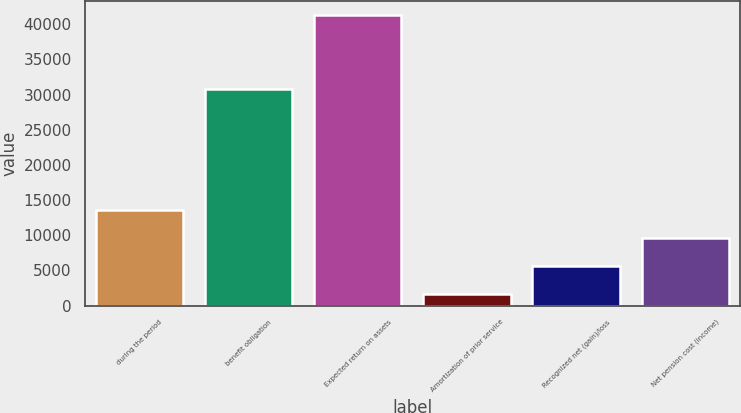<chart> <loc_0><loc_0><loc_500><loc_500><bar_chart><fcel>during the period<fcel>benefit obligation<fcel>Expected return on assets<fcel>Amortization of prior service<fcel>Recognized net (gain)/loss<fcel>Net pension cost (income)<nl><fcel>13580.3<fcel>30746<fcel>41308<fcel>1697<fcel>5658.1<fcel>9619.2<nl></chart> 